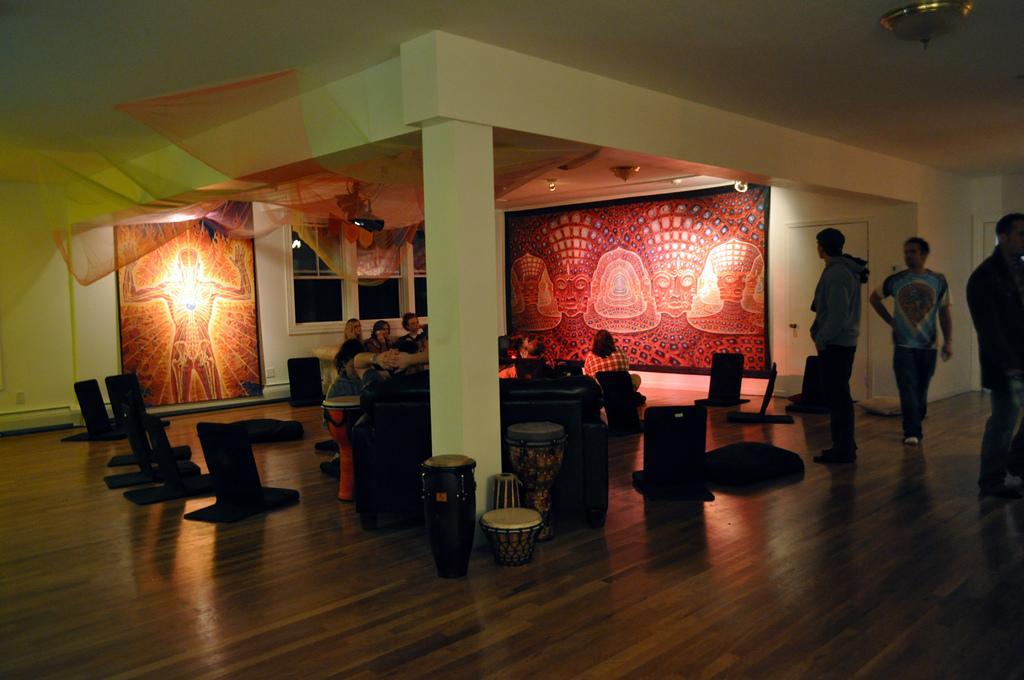How would you summarize this image in a sentence or two? In this picture we can see some group of people sitting and talking to each other and some few people are standing on the floor back side we can see One Frame that is that look like person and they are some musical instruments. 